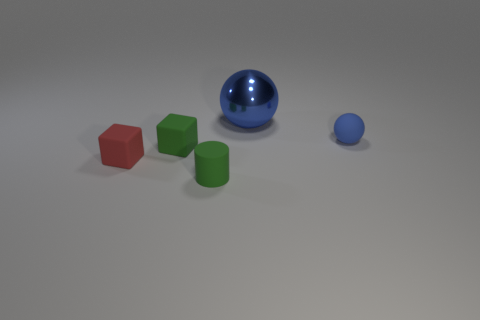Is there anything else that has the same material as the big blue object?
Keep it short and to the point. No. Are there the same number of shiny balls to the left of the big metal sphere and large green rubber blocks?
Your response must be concise. Yes. What number of other objects are there of the same shape as the shiny thing?
Offer a very short reply. 1. There is a green cylinder; what number of tiny rubber things are behind it?
Give a very brief answer. 3. There is a object that is to the right of the tiny green rubber block and left of the large object; what is its size?
Your response must be concise. Small. Are there any large red shiny spheres?
Ensure brevity in your answer.  No. What number of other things are the same size as the green cube?
Your response must be concise. 3. There is a thing behind the small blue object; is it the same color as the ball that is in front of the big blue metal sphere?
Make the answer very short. Yes. What size is the other object that is the same shape as the big blue object?
Your response must be concise. Small. Is the thing that is on the right side of the large blue shiny sphere made of the same material as the tiny green object behind the small rubber cylinder?
Your answer should be very brief. Yes. 